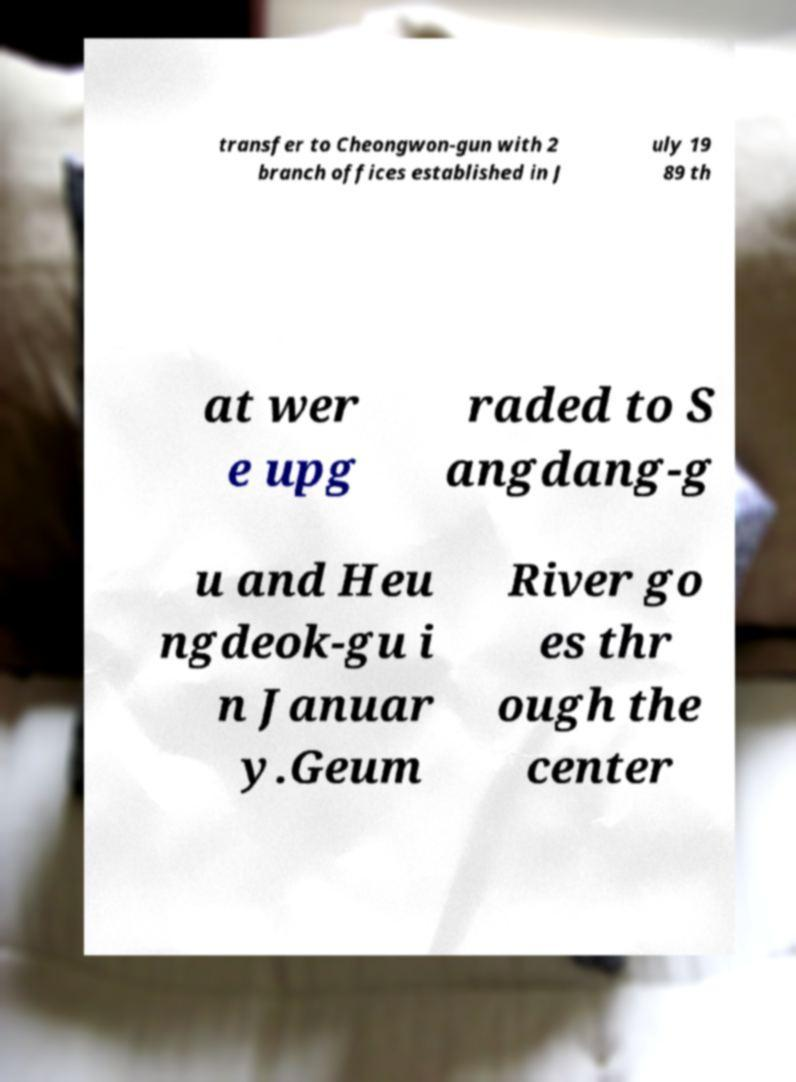Can you accurately transcribe the text from the provided image for me? transfer to Cheongwon-gun with 2 branch offices established in J uly 19 89 th at wer e upg raded to S angdang-g u and Heu ngdeok-gu i n Januar y.Geum River go es thr ough the center 